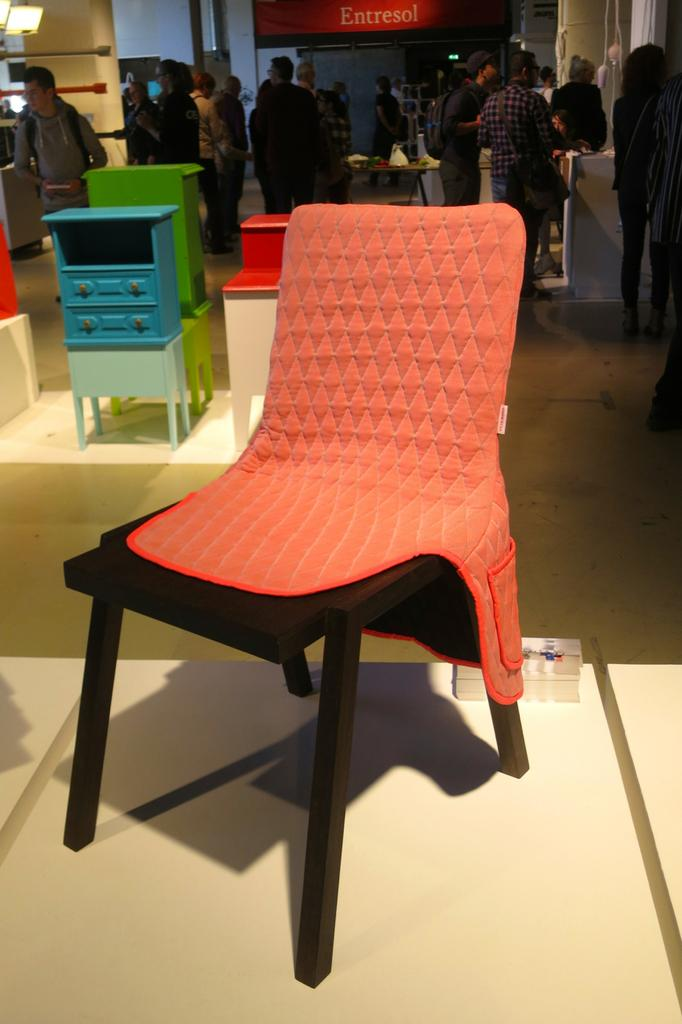What is located in the front portion of the image? There is an empty chair in the front portion of the image. What is happening in the background of the image? There are people standing and walking in the background of the image. What type of image is this? The image is of a hoarding. Can you see a trail of zebras in the image? There is no trail of zebras present in the image. 